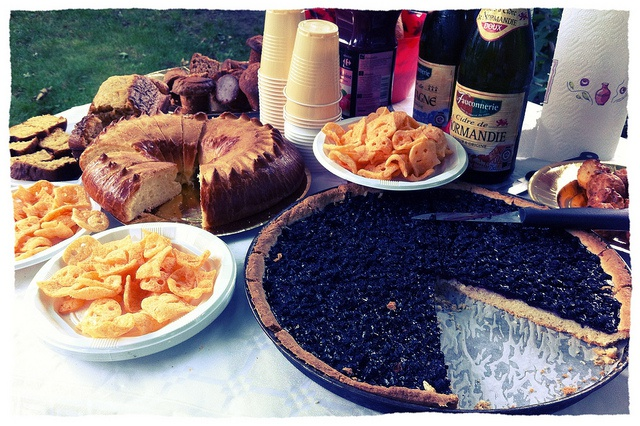Describe the objects in this image and their specific colors. I can see pizza in white, black, navy, brown, and gray tones, cake in white, black, navy, brown, and gray tones, dining table in white, navy, gray, and lightblue tones, bowl in white, khaki, and tan tones, and cake in white, black, tan, brown, and maroon tones in this image. 